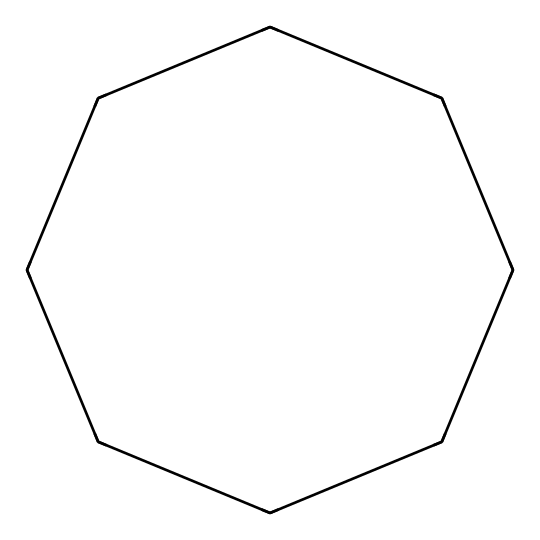What is the molecular formula of cyclooctane? The molecular formula can be determined by counting the number of carbon (C) and hydrogen (H) atoms in the structure. The SMILES representation indicates 8 carbon atoms and 16 hydrogen atoms, leading to the formula C8H16.
Answer: C8H16 How many carbon atoms are in cyclooctane? By analyzing the SMILES representation, C1CCCCCCC1, we can count the number of carbon atoms, which is 8 in total as indicated by the repeating 'C' characters.
Answer: 8 What type of molecular structure is cyclooctane? Cyclooctane has a cyclic structure as indicated by the 'C1...C1' notation in the SMILES, which represents a closed loop of carbon atoms.
Answer: cyclic What is the total number of hydrogen atoms in cyclooctane? The hydrogen atoms can be inferred from the molecular formula derived earlier, which is C8H16. The number of hydrogen atoms is indicated as 16.
Answer: 16 Why is cyclooctane classified as a cycloalkane? Cycloalkanes are hydrocarbons that contain carbon atoms arranged in a ring and have single bonds between them. Cyclooctane fits this definition due to its cyclic structure and only single carbon-carbon bonds.
Answer: due to its cyclic structure How many rings are present in cyclooctane? The structure shows a single closed loop of carbon atoms, confirming that there is only one ring present in cyclooctane.
Answer: 1 What is the degree of saturation for cyclooctane? The degree of saturation can be calculated from the molecular formula: the formula CnH2n indicates fully saturated aliphatic hydrocarbons. For 8 carbon atoms, there are 16 hydrogens, confirming it is fully saturated.
Answer: fully saturated 